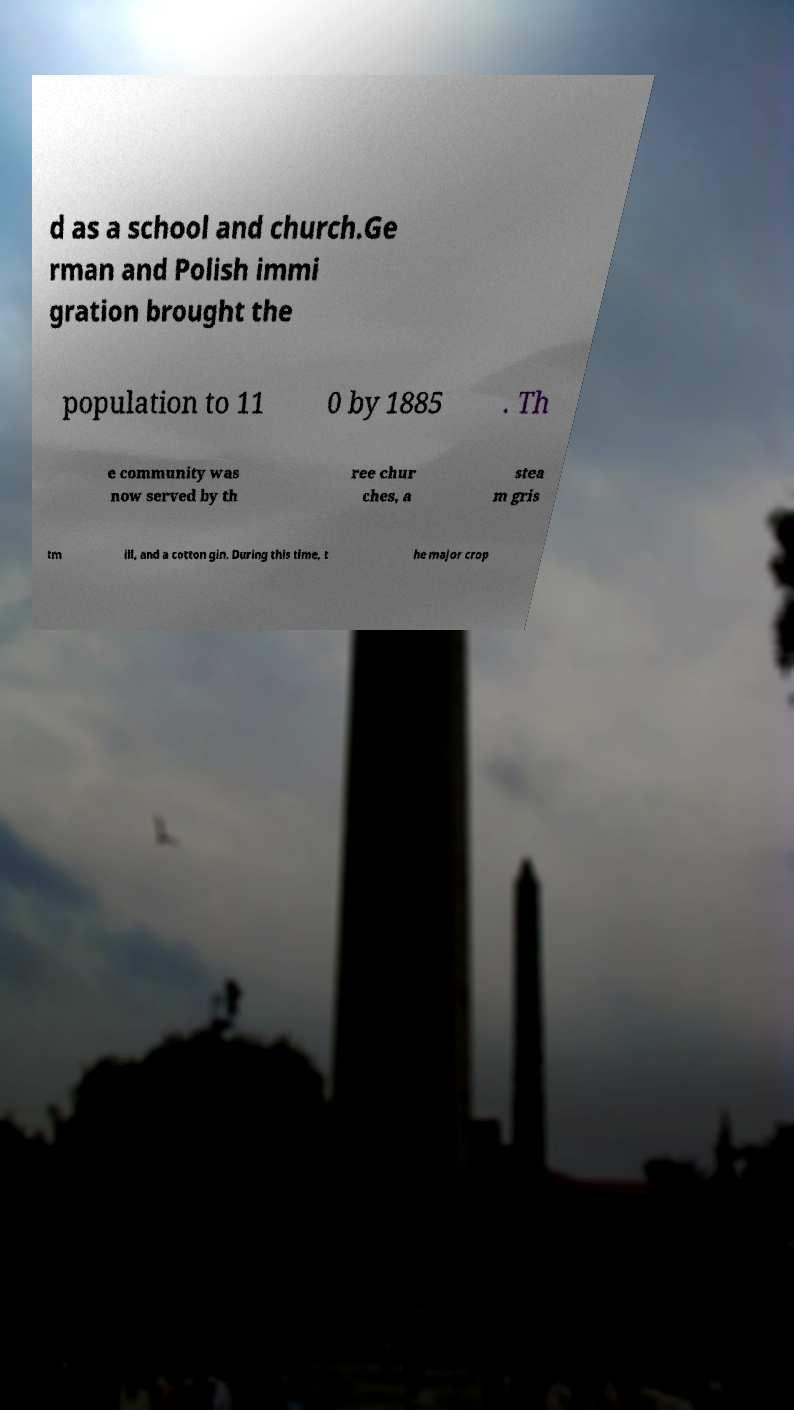Can you accurately transcribe the text from the provided image for me? d as a school and church.Ge rman and Polish immi gration brought the population to 11 0 by 1885 . Th e community was now served by th ree chur ches, a stea m gris tm ill, and a cotton gin. During this time, t he major crop 